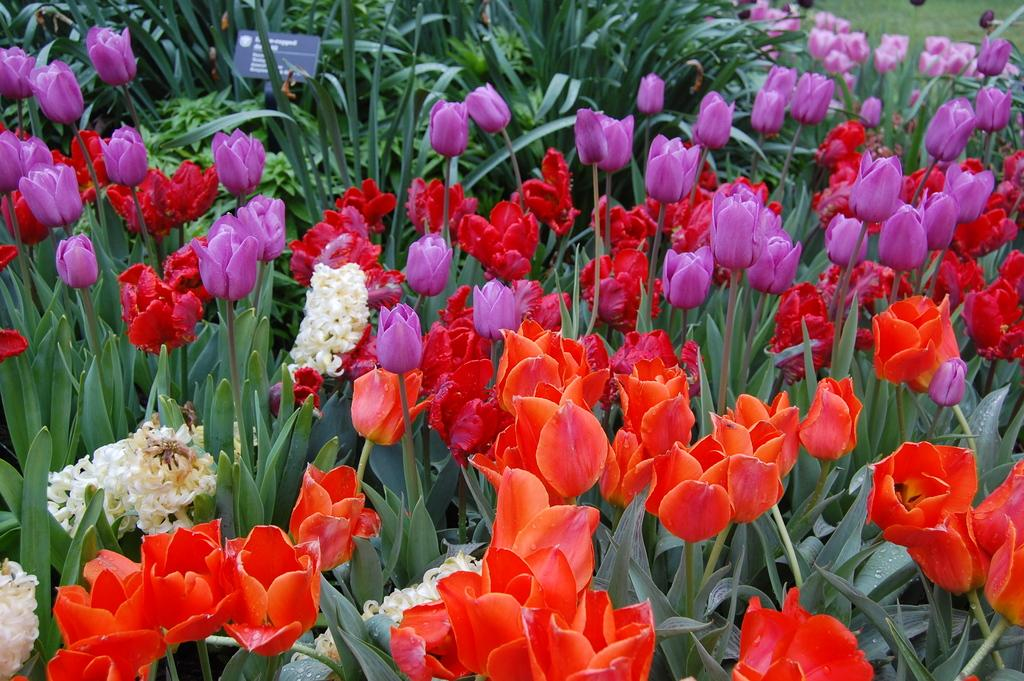What type of living organisms can be seen in the image? Plants and flowers are visible in the image. Can you describe the flowers in the image? The flowers in the image are part of the plants. How many eyes can be seen on the yam in the image? There is no yam present in the image, and therefore no eyes can be seen on it. 